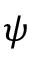<formula> <loc_0><loc_0><loc_500><loc_500>\psi</formula> 